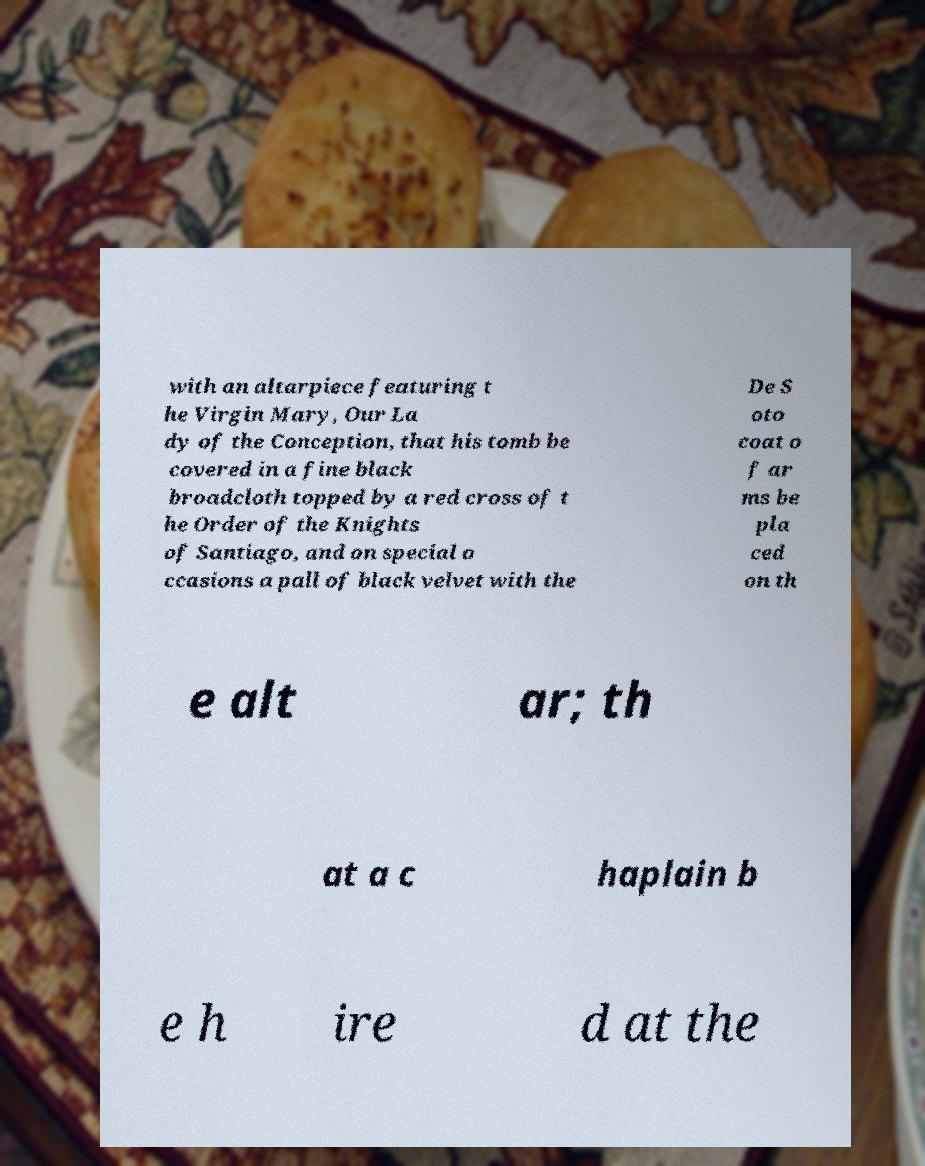For documentation purposes, I need the text within this image transcribed. Could you provide that? with an altarpiece featuring t he Virgin Mary, Our La dy of the Conception, that his tomb be covered in a fine black broadcloth topped by a red cross of t he Order of the Knights of Santiago, and on special o ccasions a pall of black velvet with the De S oto coat o f ar ms be pla ced on th e alt ar; th at a c haplain b e h ire d at the 